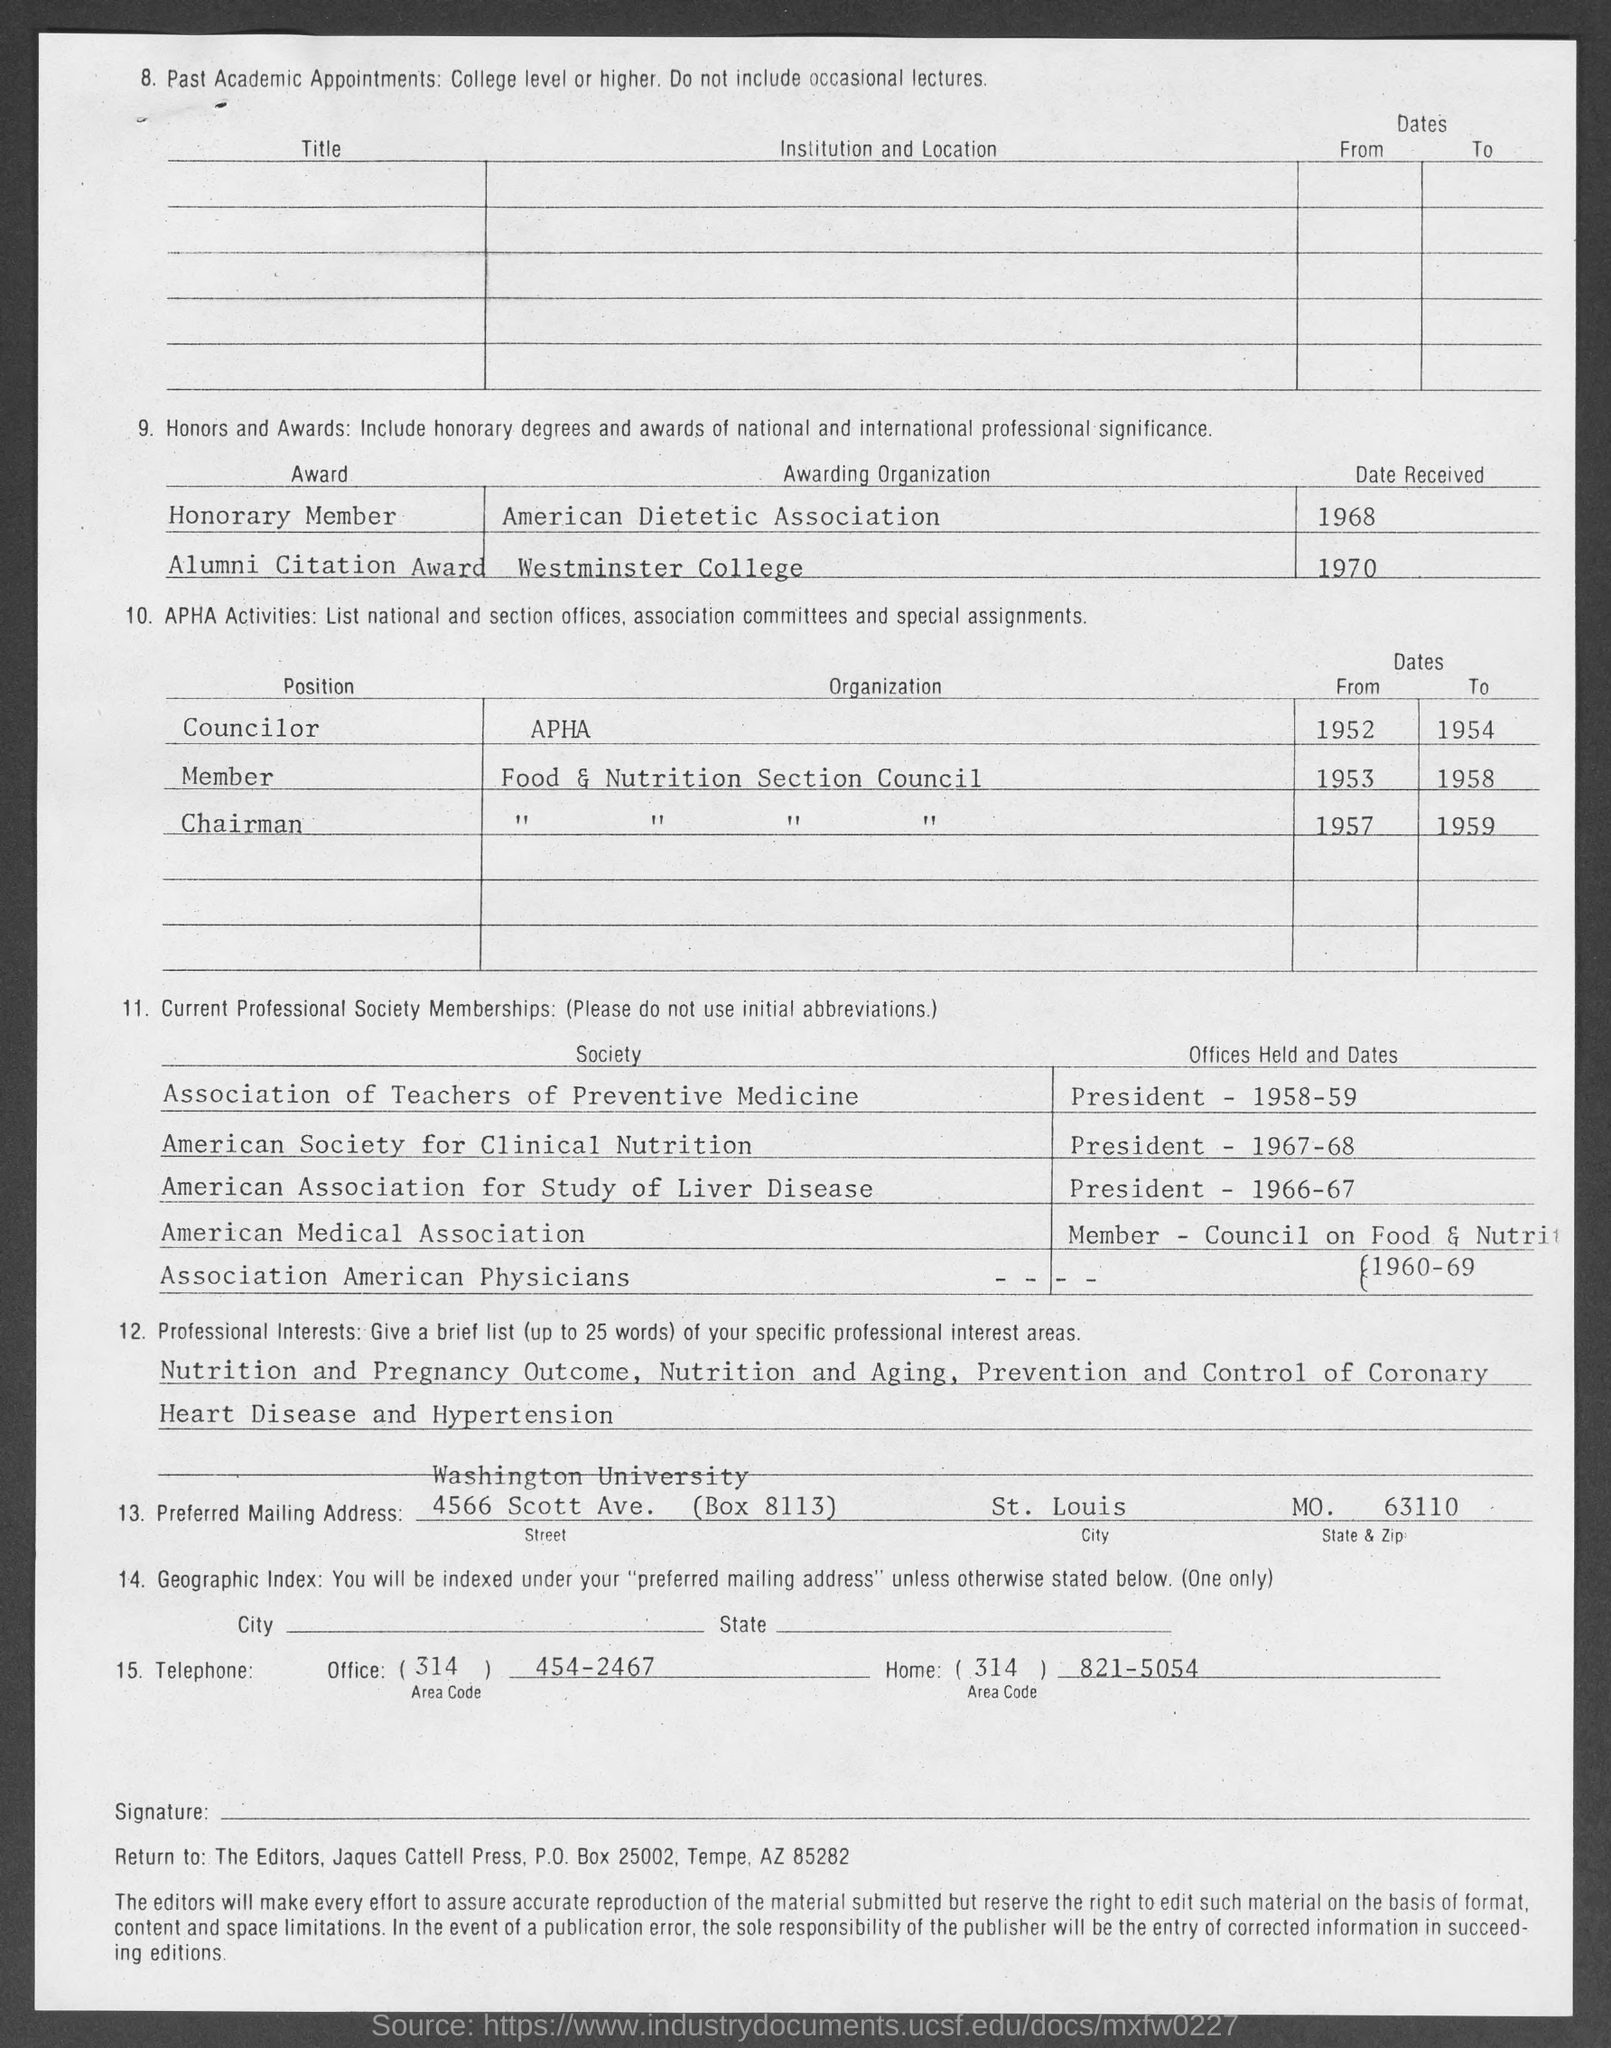What is the name of the awarding organization for the honorary member award ?
Your response must be concise. American Dietetic Association. What is the name of the awarding organization for the alumni citation award ?
Provide a succinct answer. Westminster College. On which date the honorary member award was received ?
Keep it short and to the point. 1968. On which date the alumni citation award was received ?
Your response must be concise. 1970. What is the name of the position for the organization apha as mentioned in the given page ?
Give a very brief answer. Councilor. What is the office  telephone no.  mentioned in the given page ?
Provide a short and direct response. (314) 454-2467. What is the home telephone no. mentioned in the given page ?
Make the answer very short. 821-5054. What is the state & zip mentioned in the given page ?
Provide a short and direct response. MO.  63110. What is the city mentioned in the given page ?
Provide a succinct answer. St. louis. 